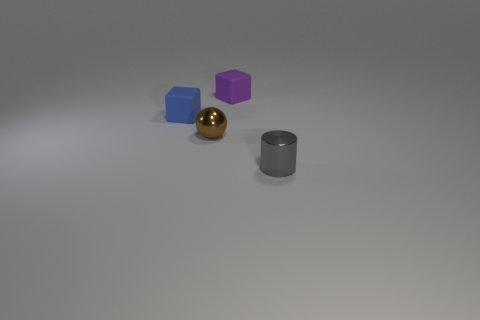Add 1 tiny purple cubes. How many objects exist? 5 Subtract all cylinders. How many objects are left? 3 Subtract 0 red cylinders. How many objects are left? 4 Subtract all large spheres. Subtract all small brown spheres. How many objects are left? 3 Add 2 cylinders. How many cylinders are left? 3 Add 1 small purple matte cubes. How many small purple matte cubes exist? 2 